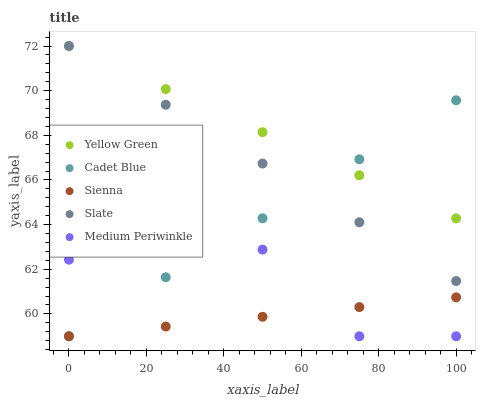Does Sienna have the minimum area under the curve?
Answer yes or no. Yes. Does Yellow Green have the maximum area under the curve?
Answer yes or no. Yes. Does Slate have the minimum area under the curve?
Answer yes or no. No. Does Slate have the maximum area under the curve?
Answer yes or no. No. Is Cadet Blue the smoothest?
Answer yes or no. Yes. Is Medium Periwinkle the roughest?
Answer yes or no. Yes. Is Slate the smoothest?
Answer yes or no. No. Is Slate the roughest?
Answer yes or no. No. Does Sienna have the lowest value?
Answer yes or no. Yes. Does Slate have the lowest value?
Answer yes or no. No. Does Yellow Green have the highest value?
Answer yes or no. Yes. Does Cadet Blue have the highest value?
Answer yes or no. No. Is Sienna less than Slate?
Answer yes or no. Yes. Is Yellow Green greater than Medium Periwinkle?
Answer yes or no. Yes. Does Cadet Blue intersect Slate?
Answer yes or no. Yes. Is Cadet Blue less than Slate?
Answer yes or no. No. Is Cadet Blue greater than Slate?
Answer yes or no. No. Does Sienna intersect Slate?
Answer yes or no. No. 